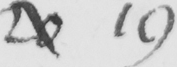Please transcribe the handwritten text in this image. 20 19 